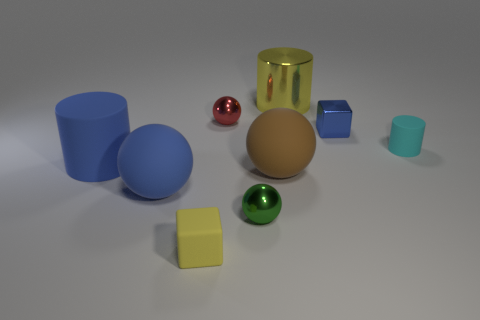Subtract all metallic cylinders. How many cylinders are left? 2 Subtract all cylinders. How many objects are left? 6 Add 1 cylinders. How many objects exist? 10 Subtract 2 cubes. How many cubes are left? 0 Subtract all red spheres. How many spheres are left? 3 Subtract all red balls. Subtract all yellow cubes. How many balls are left? 3 Subtract all brown cylinders. How many brown blocks are left? 0 Subtract all large cyan spheres. Subtract all tiny red shiny balls. How many objects are left? 8 Add 8 cubes. How many cubes are left? 10 Add 8 green metallic objects. How many green metallic objects exist? 9 